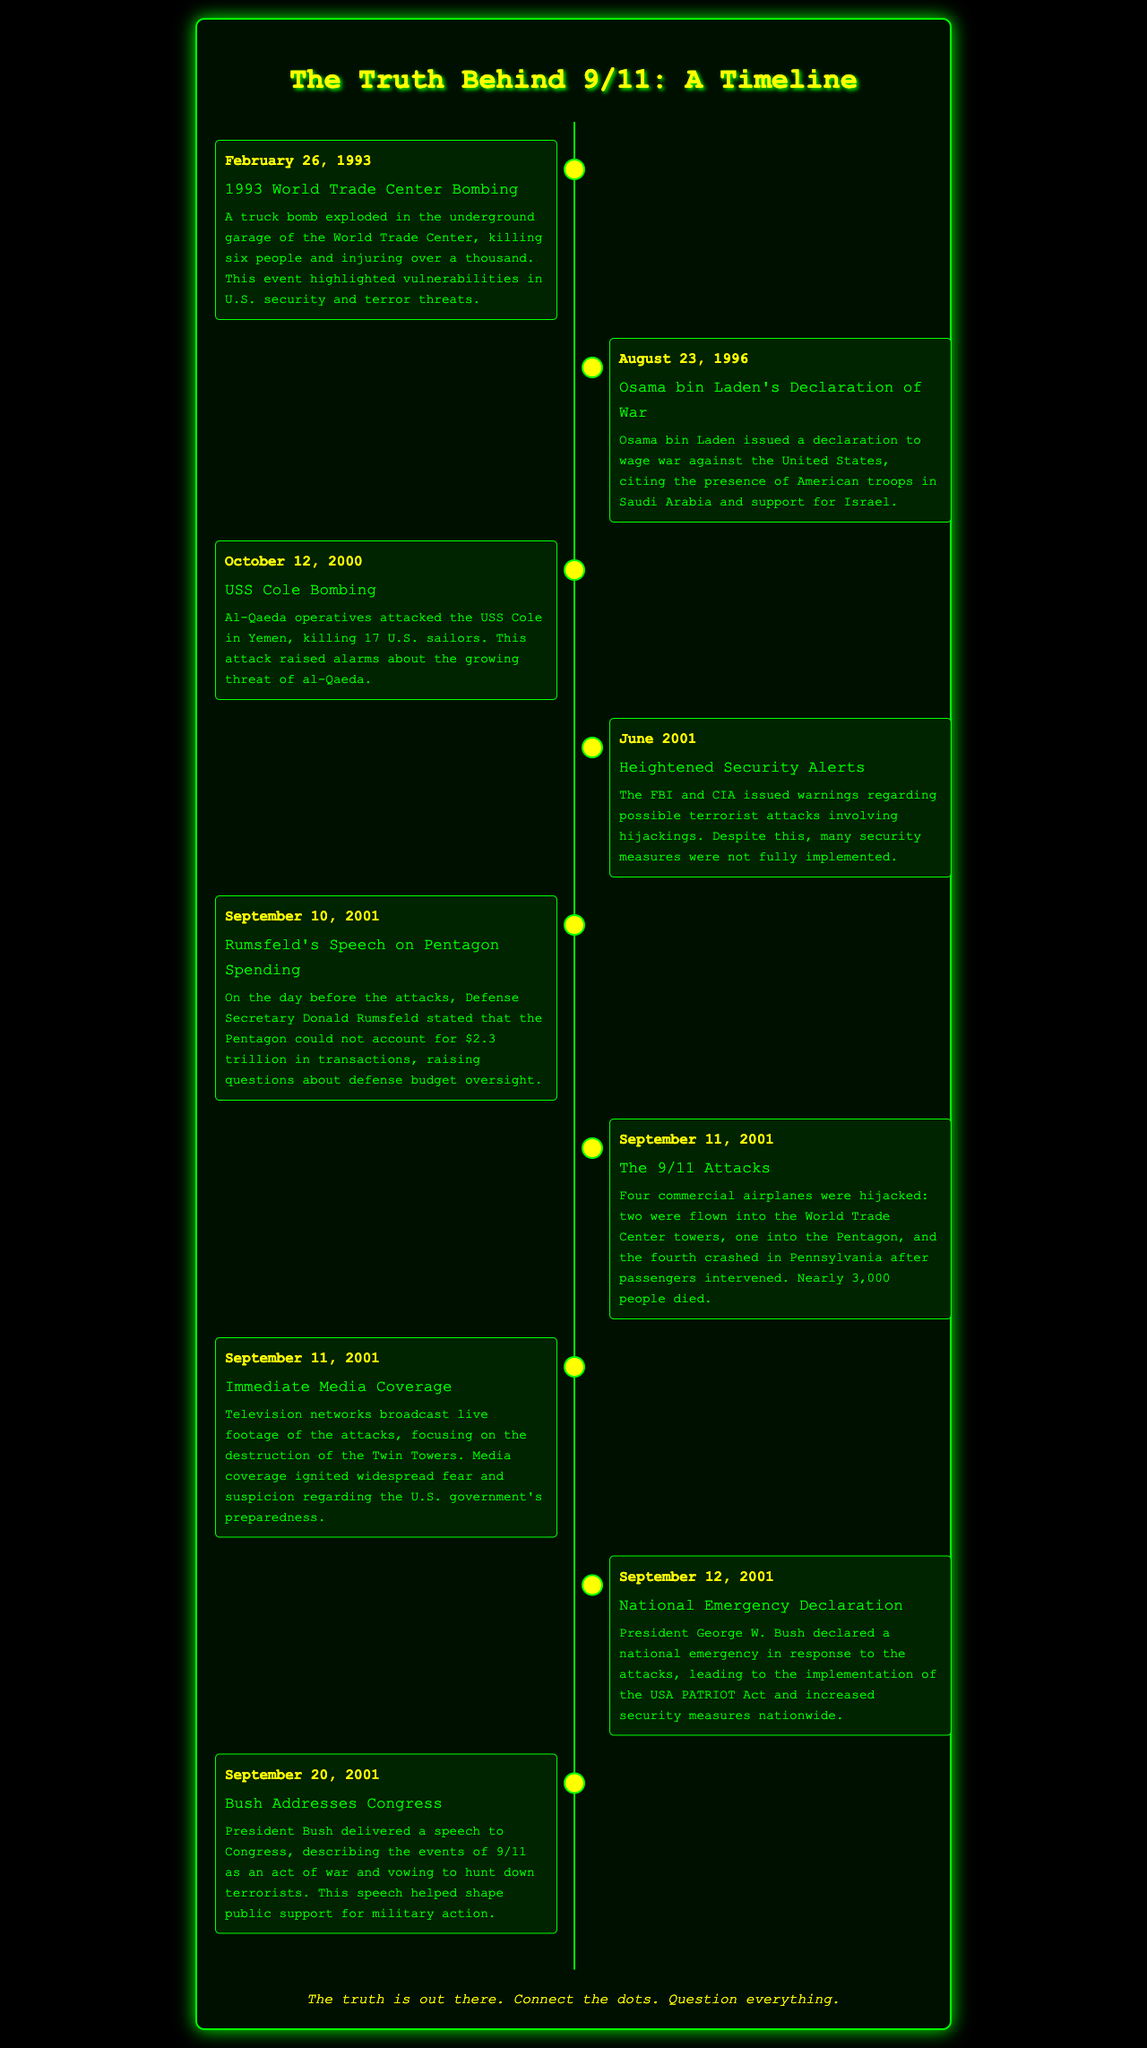what date did the 1993 World Trade Center bombing occur? The document states that the 1993 World Trade Center bombing happened on February 26, 1993.
Answer: February 26, 1993 who issued a declaration of war against the United States in 1996? According to the document, Osama bin Laden issued a declaration of war against the United States.
Answer: Osama bin Laden how many U.S. sailors were killed in the USS Cole bombing? The document specifies that 17 U.S. sailors were killed in the USS Cole bombing.
Answer: 17 what was declared by President Bush on September 12, 2001? The document mentions that President Bush declared a national emergency on September 12, 2001.
Answer: national emergency what event does President Bush refer to as an act of war? The document states that President Bush described the events of 9/11 as an act of war in his speech to Congress.
Answer: events of 9/11 what significant financial figure did Rumsfeld mention on September 10, 2001? The document highlights that Rumsfeld stated the Pentagon could not account for $2.3 trillion in transactions.
Answer: $2.3 trillion what event occurred on September 11, 2001, that involved multiple hijacked airplanes? The document indicates that four commercial airplanes were hijacked on September 11, 2001.
Answer: four commercial airplanes what was the main focus of immediate media coverage following the attacks? The document reveals that media coverage focused on the destruction of the Twin Towers following the attacks.
Answer: destruction of the Twin Towers what did the USA PATRIOT Act result from? The document links the implementation of the USA PATRIOT Act to the national emergency declared by President Bush in response to the attacks.
Answer: national emergency 